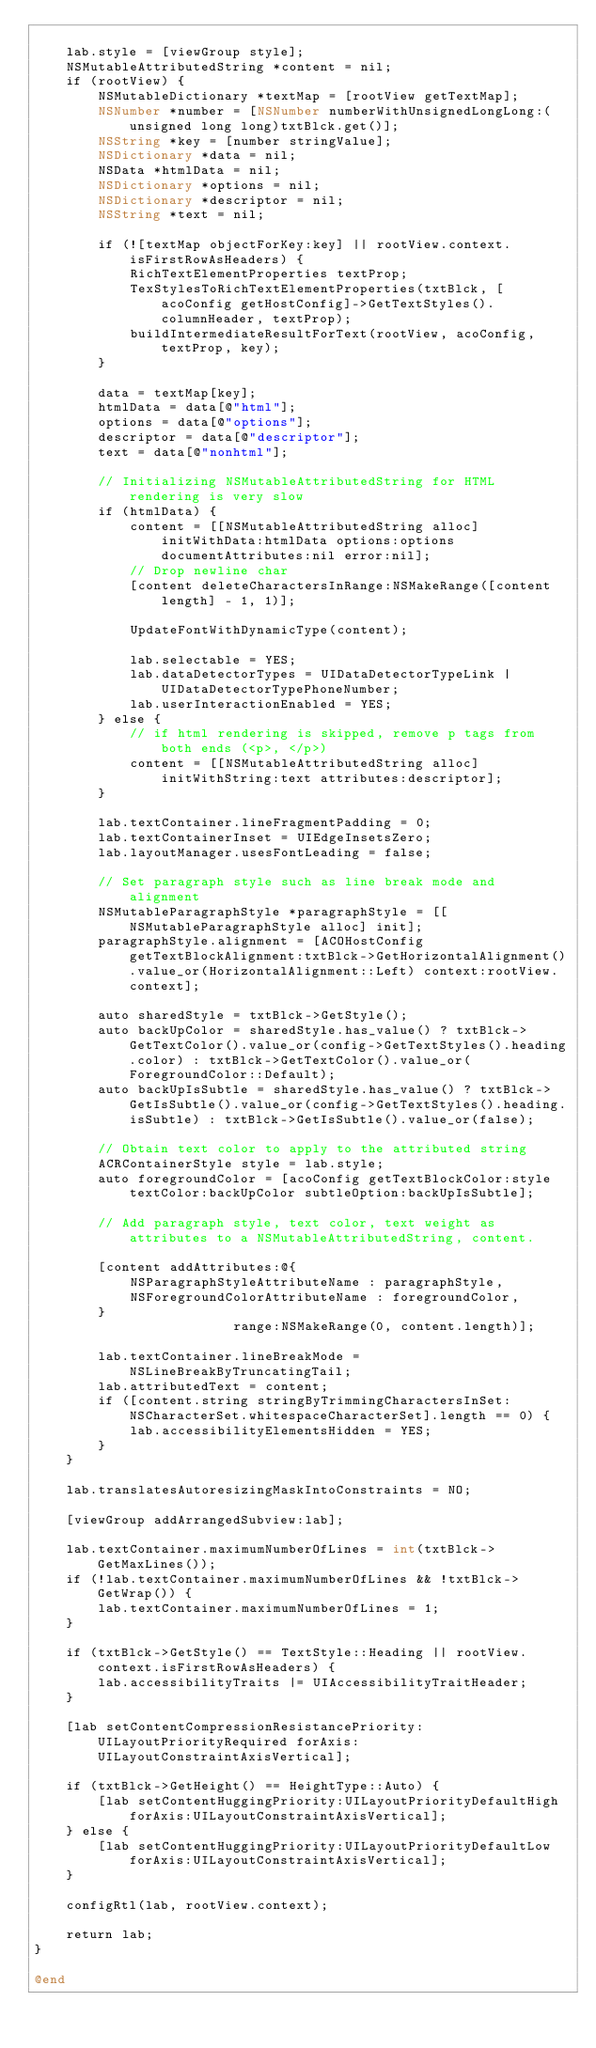<code> <loc_0><loc_0><loc_500><loc_500><_ObjectiveC_>
    lab.style = [viewGroup style];
    NSMutableAttributedString *content = nil;
    if (rootView) {
        NSMutableDictionary *textMap = [rootView getTextMap];
        NSNumber *number = [NSNumber numberWithUnsignedLongLong:(unsigned long long)txtBlck.get()];
        NSString *key = [number stringValue];
        NSDictionary *data = nil;
        NSData *htmlData = nil;
        NSDictionary *options = nil;
        NSDictionary *descriptor = nil;
        NSString *text = nil;

        if (![textMap objectForKey:key] || rootView.context.isFirstRowAsHeaders) {
            RichTextElementProperties textProp;
            TexStylesToRichTextElementProperties(txtBlck, [acoConfig getHostConfig]->GetTextStyles().columnHeader, textProp);
            buildIntermediateResultForText(rootView, acoConfig, textProp, key);
        }

        data = textMap[key];
        htmlData = data[@"html"];
        options = data[@"options"];
        descriptor = data[@"descriptor"];
        text = data[@"nonhtml"];

        // Initializing NSMutableAttributedString for HTML rendering is very slow
        if (htmlData) {
            content = [[NSMutableAttributedString alloc] initWithData:htmlData options:options documentAttributes:nil error:nil];
            // Drop newline char
            [content deleteCharactersInRange:NSMakeRange([content length] - 1, 1)];

            UpdateFontWithDynamicType(content);

            lab.selectable = YES;
            lab.dataDetectorTypes = UIDataDetectorTypeLink | UIDataDetectorTypePhoneNumber;
            lab.userInteractionEnabled = YES;
        } else {
            // if html rendering is skipped, remove p tags from both ends (<p>, </p>)
            content = [[NSMutableAttributedString alloc] initWithString:text attributes:descriptor];
        }

        lab.textContainer.lineFragmentPadding = 0;
        lab.textContainerInset = UIEdgeInsetsZero;
        lab.layoutManager.usesFontLeading = false;

        // Set paragraph style such as line break mode and alignment
        NSMutableParagraphStyle *paragraphStyle = [[NSMutableParagraphStyle alloc] init];
        paragraphStyle.alignment = [ACOHostConfig getTextBlockAlignment:txtBlck->GetHorizontalAlignment().value_or(HorizontalAlignment::Left) context:rootView.context];

        auto sharedStyle = txtBlck->GetStyle();
        auto backUpColor = sharedStyle.has_value() ? txtBlck->GetTextColor().value_or(config->GetTextStyles().heading.color) : txtBlck->GetTextColor().value_or(ForegroundColor::Default);
        auto backUpIsSubtle = sharedStyle.has_value() ? txtBlck->GetIsSubtle().value_or(config->GetTextStyles().heading.isSubtle) : txtBlck->GetIsSubtle().value_or(false);

        // Obtain text color to apply to the attributed string
        ACRContainerStyle style = lab.style;
        auto foregroundColor = [acoConfig getTextBlockColor:style textColor:backUpColor subtleOption:backUpIsSubtle];

        // Add paragraph style, text color, text weight as attributes to a NSMutableAttributedString, content.

        [content addAttributes:@{
            NSParagraphStyleAttributeName : paragraphStyle,
            NSForegroundColorAttributeName : foregroundColor,
        }
                         range:NSMakeRange(0, content.length)];

        lab.textContainer.lineBreakMode = NSLineBreakByTruncatingTail;
        lab.attributedText = content;
        if ([content.string stringByTrimmingCharactersInSet:NSCharacterSet.whitespaceCharacterSet].length == 0) {
            lab.accessibilityElementsHidden = YES;
        }
    }

    lab.translatesAutoresizingMaskIntoConstraints = NO;

    [viewGroup addArrangedSubview:lab];

    lab.textContainer.maximumNumberOfLines = int(txtBlck->GetMaxLines());
    if (!lab.textContainer.maximumNumberOfLines && !txtBlck->GetWrap()) {
        lab.textContainer.maximumNumberOfLines = 1;
    }

    if (txtBlck->GetStyle() == TextStyle::Heading || rootView.context.isFirstRowAsHeaders) {
        lab.accessibilityTraits |= UIAccessibilityTraitHeader;
    }

    [lab setContentCompressionResistancePriority:UILayoutPriorityRequired forAxis:UILayoutConstraintAxisVertical];

    if (txtBlck->GetHeight() == HeightType::Auto) {
        [lab setContentHuggingPriority:UILayoutPriorityDefaultHigh forAxis:UILayoutConstraintAxisVertical];
    } else {
        [lab setContentHuggingPriority:UILayoutPriorityDefaultLow forAxis:UILayoutConstraintAxisVertical];
    }

    configRtl(lab, rootView.context);

    return lab;
}

@end
</code> 